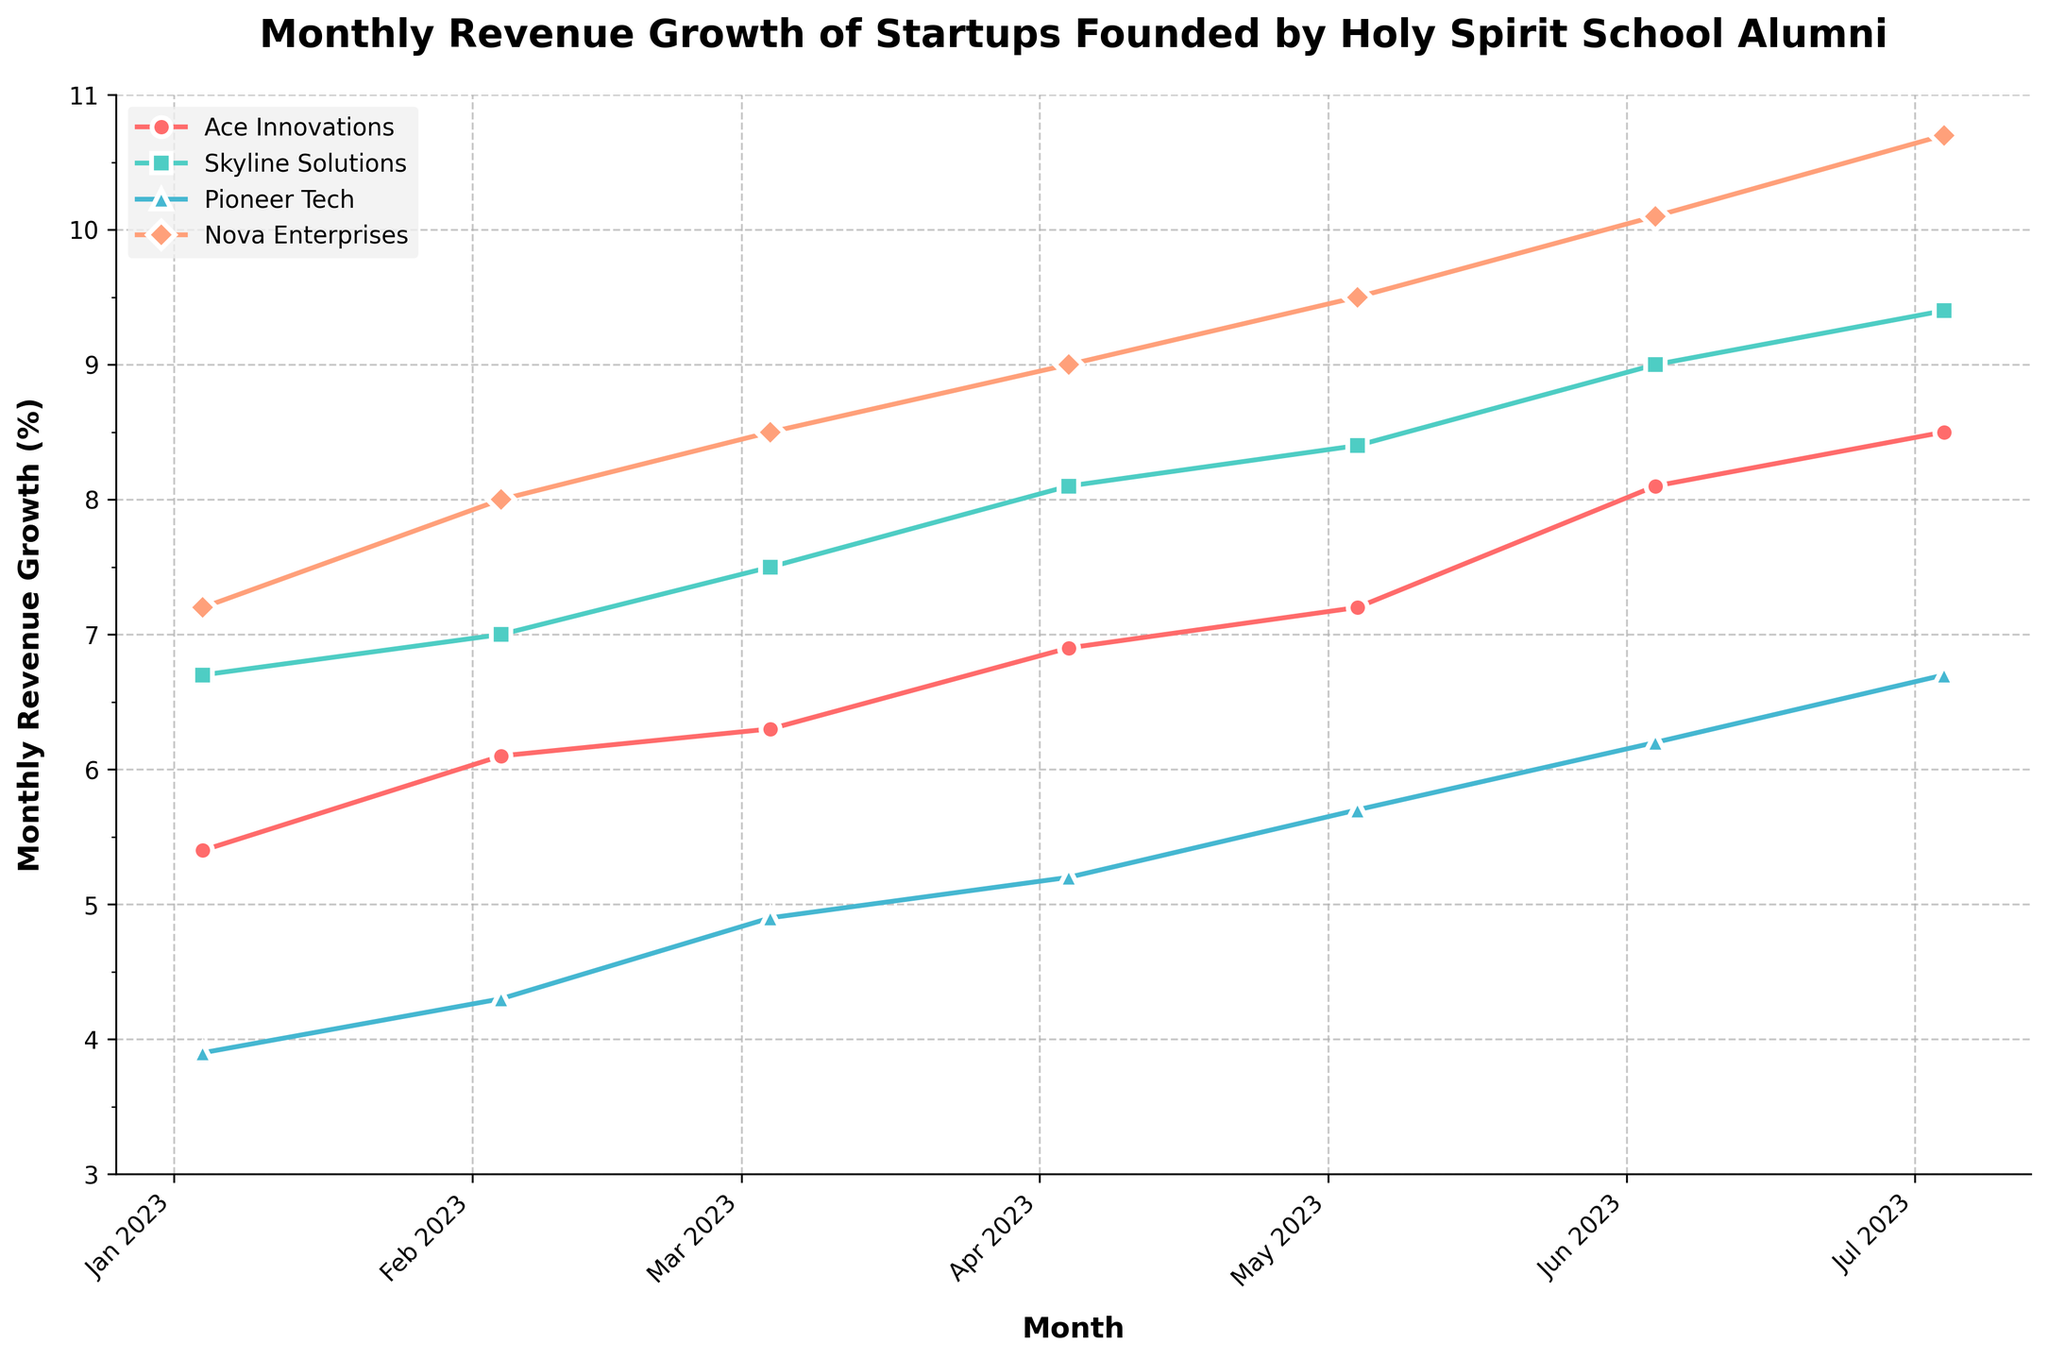What is the title of the plot? The title is usually displayed at the top of the plot, summarizing what the figure is about. In this case, it is clearly marked.
Answer: Monthly Revenue Growth of Startups Founded by Holy Spirit School Alumni Which company had the highest revenue growth in January 2023? By checking the data points for January 2023 on the plot, Nova Enterprises shows the highest revenue growth.
Answer: Nova Enterprises What is the color of the line representing Ace Innovations? Each company is given a specific color. According to the color key, Ace Innovations is represented by a specific color.
Answer: Red From February to March 2023, which company's revenue growth increased the least? By comparing the growth from February to March, Pioneer Tech's growth increases the least.
Answer: Pioneer Tech Which month shows the highest revenue growth for Pioneer Tech? By following the plot line specific to Pioneer Tech, the peak point appears in July 2023.
Answer: July 2023 What is the average monthly revenue growth for Nova Enterprises from January to July 2023? Summing the values (7.2 + 8.0 + 8.5 + 9.0 + 9.5 + 10.1 + 10.7) gives us 63, and dividing by 7 months yields the average.
Answer: 9 Which two companies show the closest revenue growth values in June 2023? By comparing the values for each company in June, Ace Innovations and Pioneer Tech have growth values nearest each other.
Answer: Ace Innovations and Skyline Solutions Between January and July 2023, which company showed the largest overall growth in monthly revenue? Comparing the January and July values for each company and subtracting, Nova Enterprises shows the largest growth (10.7 - 7.2 = 3.5%).
Answer: Nova Enterprises What is the range of monthly revenue growth for Skyline Solutions over the plotted period? Finding the highest and lowest values across the months for Skyline Solutions and subtracting gives us the range (9.4 - 6.7 = 2.7%).
Answer: 2.7% 